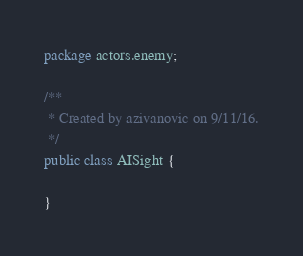<code> <loc_0><loc_0><loc_500><loc_500><_Java_>package actors.enemy;

/**
 * Created by azivanovic on 9/11/16.
 */
public class AISight {

}
</code> 